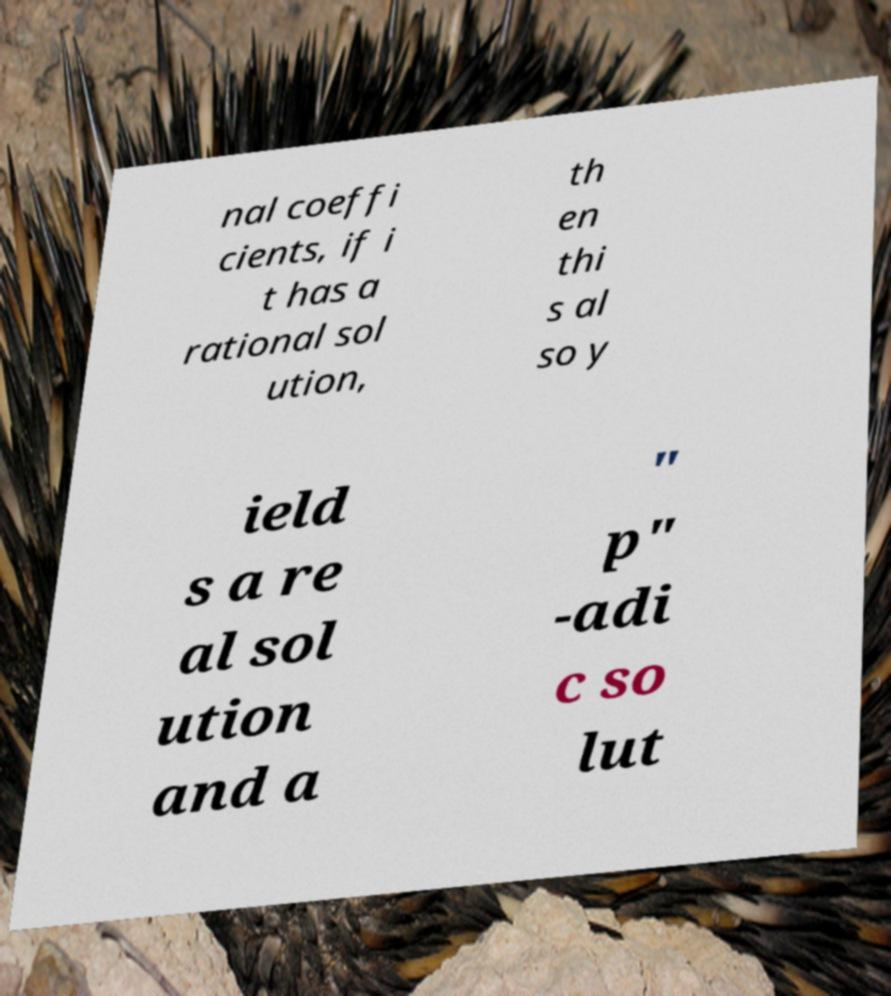I need the written content from this picture converted into text. Can you do that? nal coeffi cients, if i t has a rational sol ution, th en thi s al so y ield s a re al sol ution and a " p" -adi c so lut 